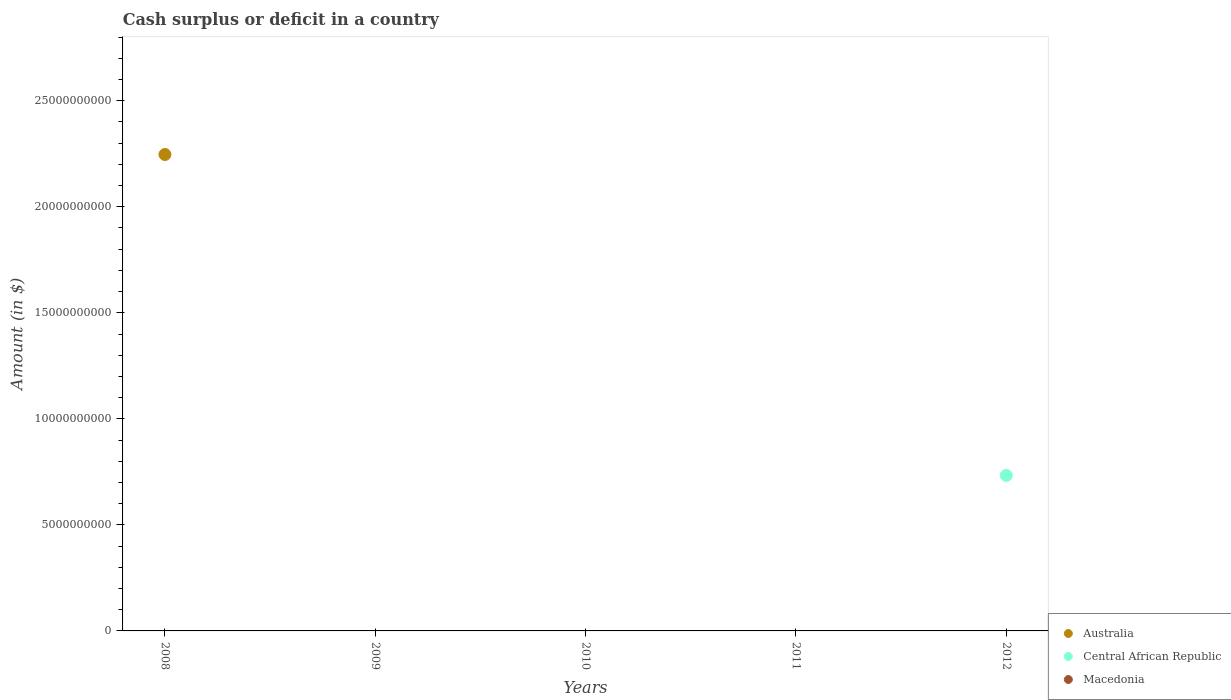How many different coloured dotlines are there?
Your answer should be compact. 2. Is the number of dotlines equal to the number of legend labels?
Your answer should be very brief. No. What is the amount of cash surplus or deficit in Australia in 2011?
Offer a very short reply. 0. Across all years, what is the maximum amount of cash surplus or deficit in Australia?
Your answer should be compact. 2.25e+1. Across all years, what is the minimum amount of cash surplus or deficit in Macedonia?
Provide a succinct answer. 0. In which year was the amount of cash surplus or deficit in Australia maximum?
Give a very brief answer. 2008. What is the total amount of cash surplus or deficit in Australia in the graph?
Make the answer very short. 2.25e+1. What is the difference between the amount of cash surplus or deficit in Macedonia in 2012 and the amount of cash surplus or deficit in Central African Republic in 2010?
Offer a very short reply. 0. What is the average amount of cash surplus or deficit in Macedonia per year?
Make the answer very short. 0. In how many years, is the amount of cash surplus or deficit in Central African Republic greater than 16000000000 $?
Provide a short and direct response. 0. What is the difference between the highest and the lowest amount of cash surplus or deficit in Australia?
Provide a short and direct response. 2.25e+1. What is the difference between two consecutive major ticks on the Y-axis?
Offer a very short reply. 5.00e+09. Are the values on the major ticks of Y-axis written in scientific E-notation?
Provide a succinct answer. No. Does the graph contain any zero values?
Your answer should be very brief. Yes. How many legend labels are there?
Your answer should be compact. 3. What is the title of the graph?
Your response must be concise. Cash surplus or deficit in a country. What is the label or title of the Y-axis?
Give a very brief answer. Amount (in $). What is the Amount (in $) in Australia in 2008?
Ensure brevity in your answer.  2.25e+1. What is the Amount (in $) of Macedonia in 2008?
Give a very brief answer. 0. What is the Amount (in $) in Australia in 2009?
Offer a terse response. 0. What is the Amount (in $) of Central African Republic in 2009?
Ensure brevity in your answer.  0. What is the Amount (in $) in Macedonia in 2009?
Provide a succinct answer. 0. What is the Amount (in $) of Australia in 2010?
Your response must be concise. 0. What is the Amount (in $) of Central African Republic in 2010?
Your response must be concise. 0. What is the Amount (in $) of Central African Republic in 2012?
Keep it short and to the point. 7.33e+09. What is the Amount (in $) of Macedonia in 2012?
Ensure brevity in your answer.  0. Across all years, what is the maximum Amount (in $) in Australia?
Keep it short and to the point. 2.25e+1. Across all years, what is the maximum Amount (in $) of Central African Republic?
Provide a succinct answer. 7.33e+09. Across all years, what is the minimum Amount (in $) in Central African Republic?
Your response must be concise. 0. What is the total Amount (in $) of Australia in the graph?
Provide a short and direct response. 2.25e+1. What is the total Amount (in $) in Central African Republic in the graph?
Your answer should be very brief. 7.33e+09. What is the total Amount (in $) in Macedonia in the graph?
Offer a terse response. 0. What is the difference between the Amount (in $) of Australia in 2008 and the Amount (in $) of Central African Republic in 2012?
Offer a terse response. 1.51e+1. What is the average Amount (in $) of Australia per year?
Your response must be concise. 4.49e+09. What is the average Amount (in $) of Central African Republic per year?
Offer a terse response. 1.47e+09. What is the difference between the highest and the lowest Amount (in $) in Australia?
Ensure brevity in your answer.  2.25e+1. What is the difference between the highest and the lowest Amount (in $) in Central African Republic?
Make the answer very short. 7.33e+09. 